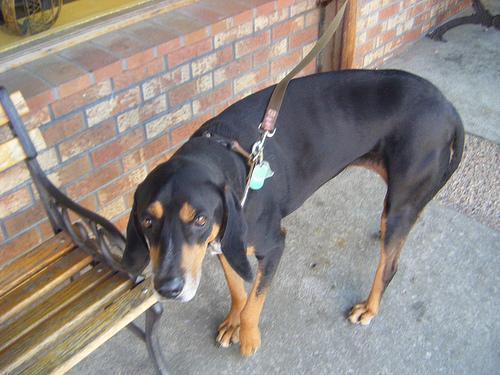How many dogs are in the shot?
Give a very brief answer. 1. 